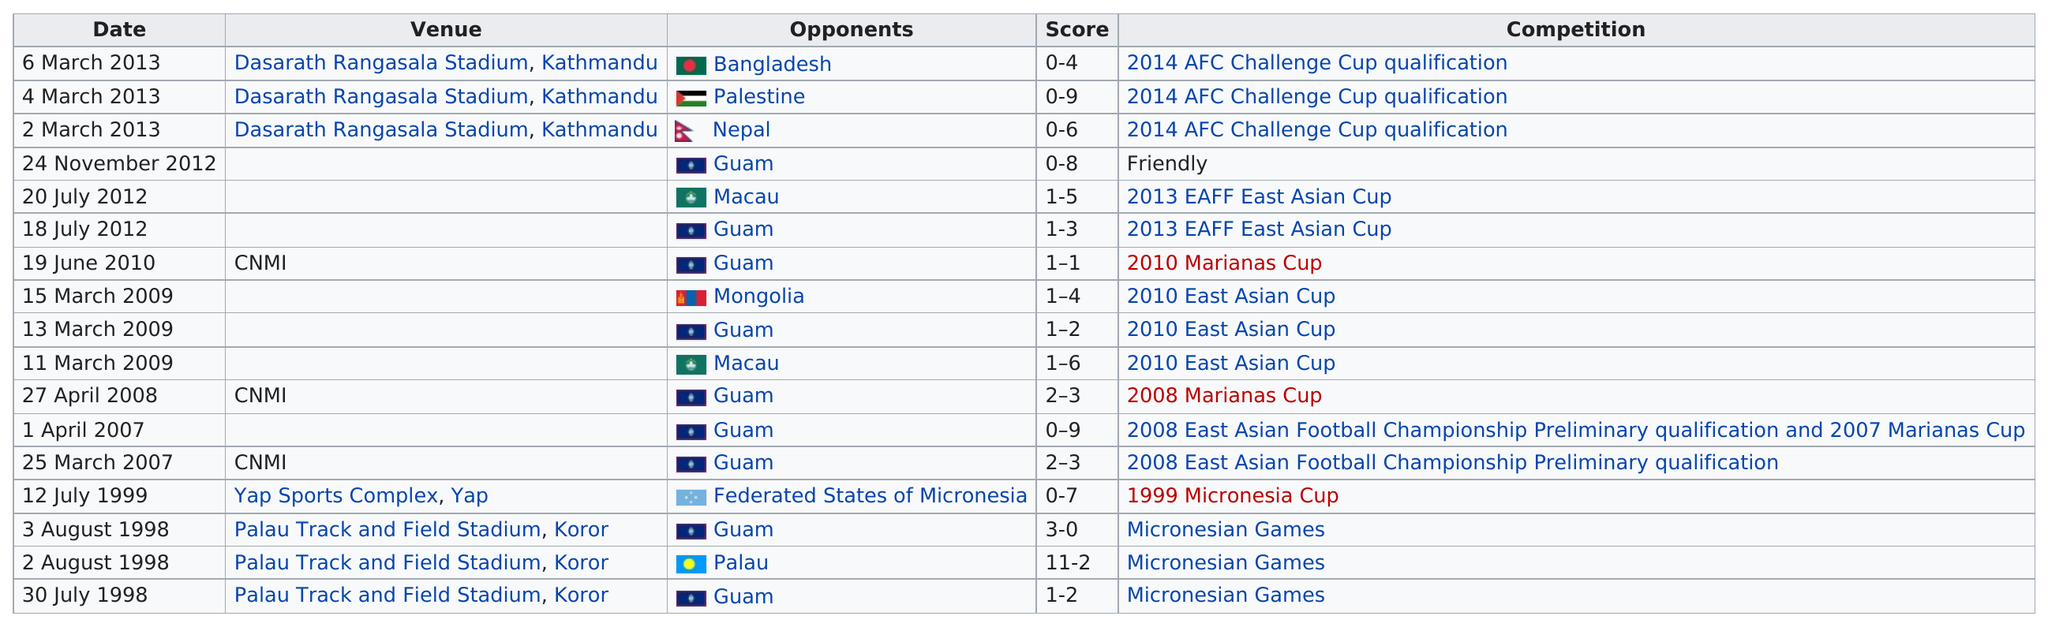Outline some significant characteristics in this image. The CNMI, along with other venues such as Dasarath Rangasala Stadium in Kathmandu, Yap Sports Complex in Yap, and Palau Track and Field Stadium in Koror, will host the 2023 Southeast Asian Games. The number of victories recorded is 2... The date that is listed after July 20th, 2012 is July 18th, 2012. Guam was an opponent a total of 9 times. The Palau Track and Field Stadium has been played in more frequently compared to the Yap Sports Complex. 